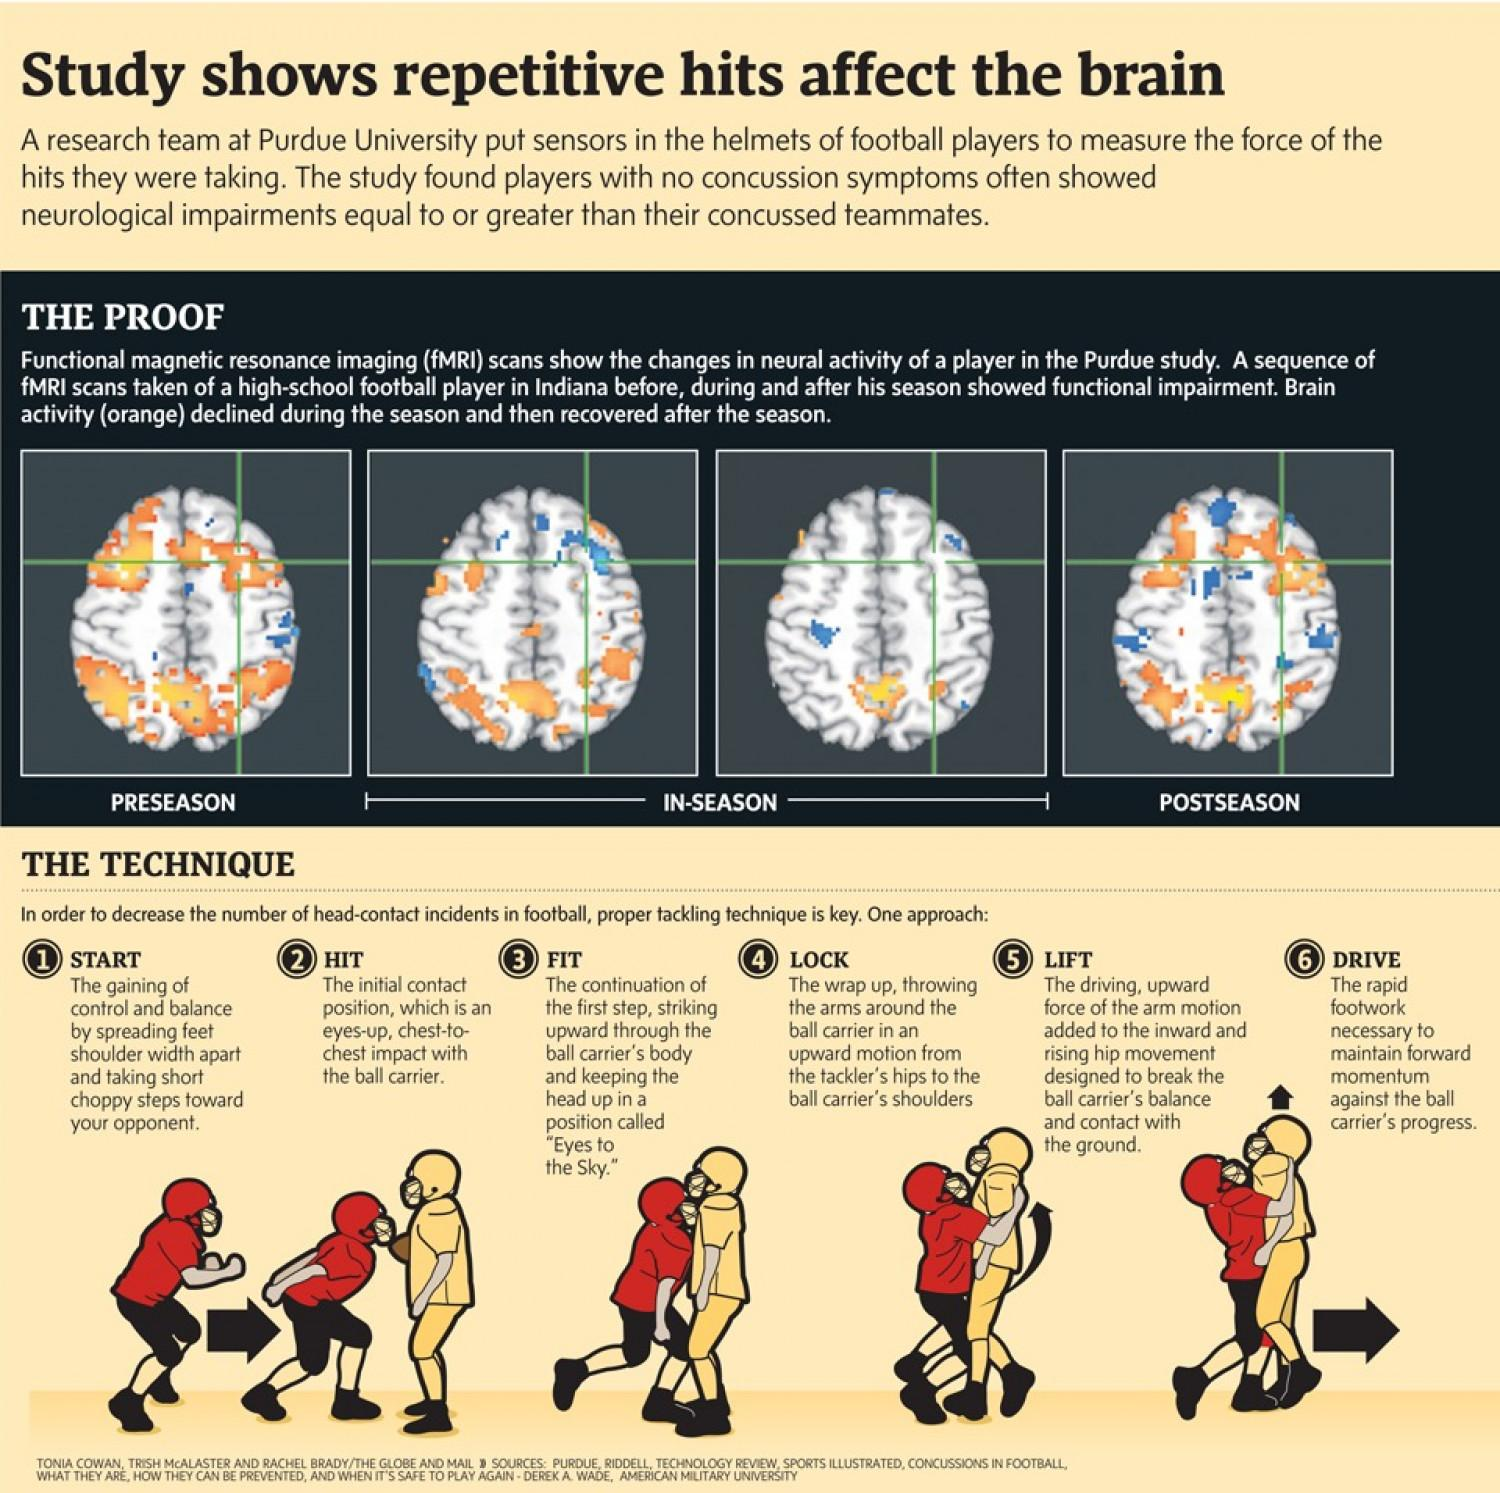Highlight a few significant elements in this photo. This infographic displays 4 functional fMRI scan images. 